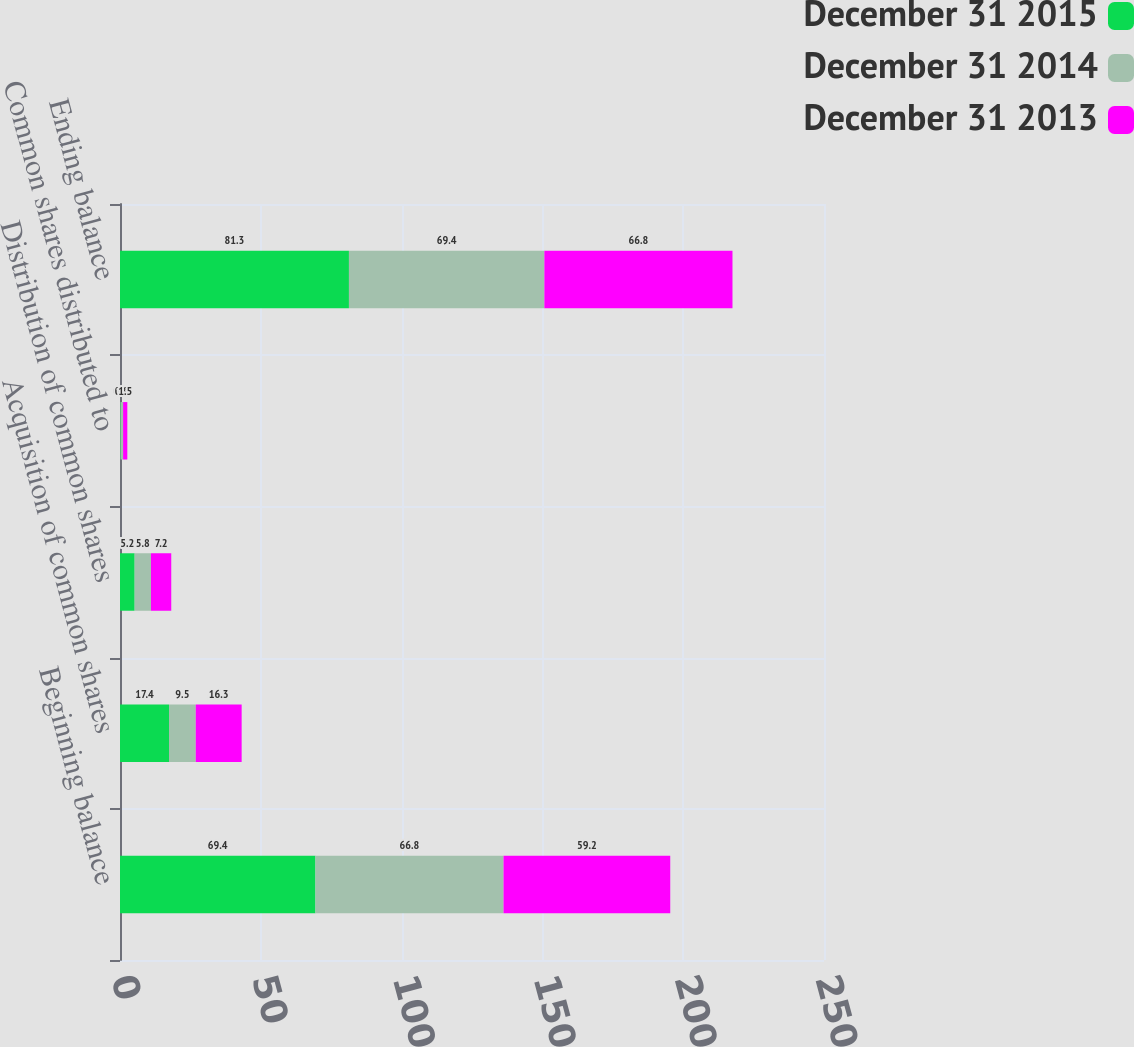Convert chart. <chart><loc_0><loc_0><loc_500><loc_500><stacked_bar_chart><ecel><fcel>Beginning balance<fcel>Acquisition of common shares<fcel>Distribution of common shares<fcel>Common shares distributed to<fcel>Ending balance<nl><fcel>December 31 2015<fcel>69.4<fcel>17.4<fcel>5.2<fcel>0.2<fcel>81.3<nl><fcel>December 31 2014<fcel>66.8<fcel>9.5<fcel>5.8<fcel>0.9<fcel>69.4<nl><fcel>December 31 2013<fcel>59.2<fcel>16.3<fcel>7.2<fcel>1.5<fcel>66.8<nl></chart> 